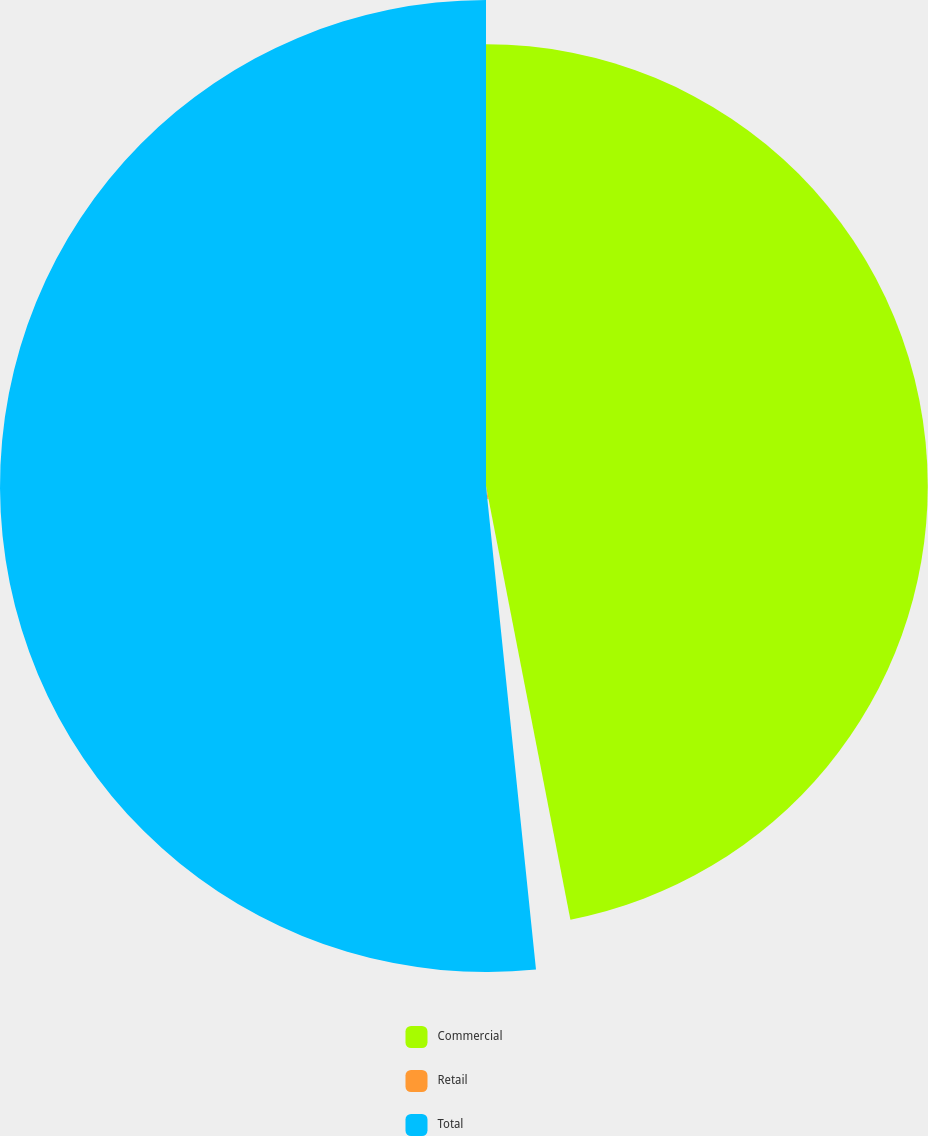Convert chart. <chart><loc_0><loc_0><loc_500><loc_500><pie_chart><fcel>Commercial<fcel>Retail<fcel>Total<nl><fcel>46.94%<fcel>1.42%<fcel>51.64%<nl></chart> 